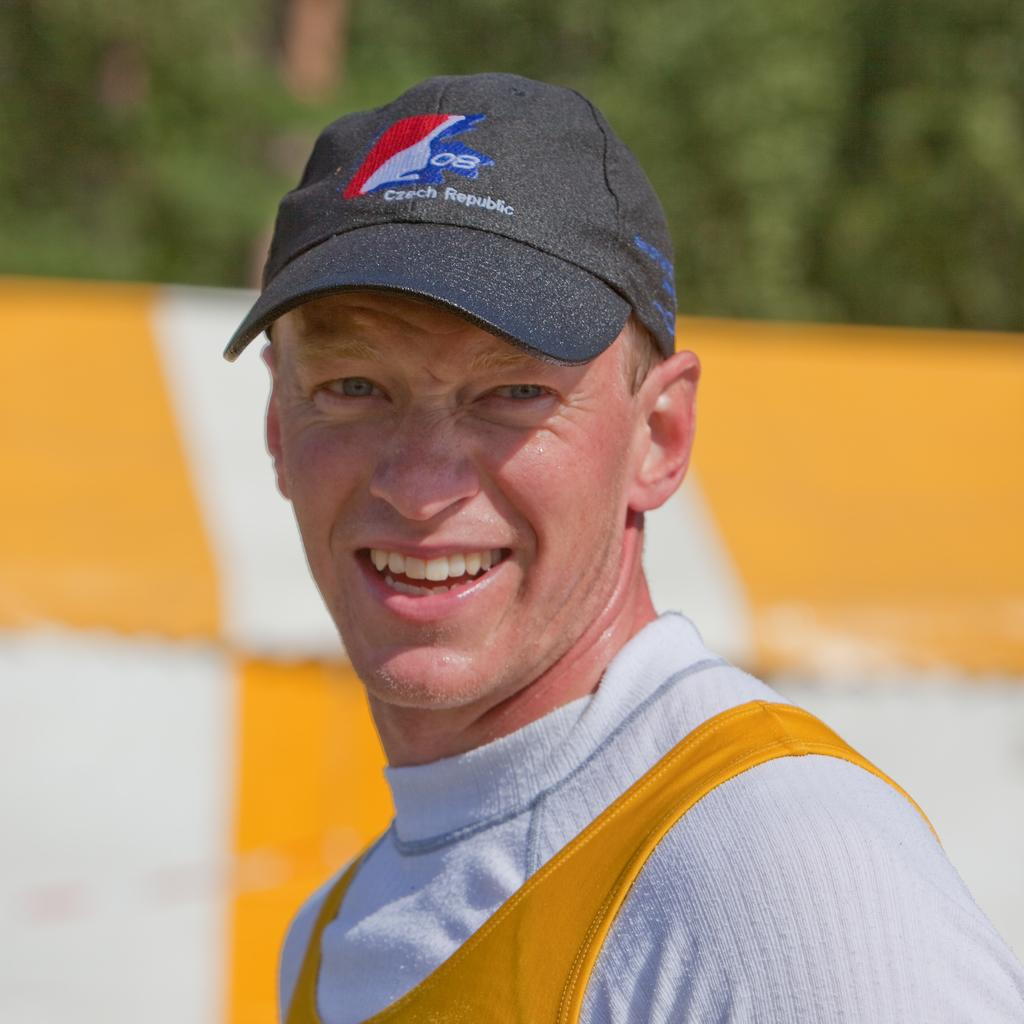Provide a one-sentence caption for the provided image. A man wearing a Czech Republic baseball hat smiles. 